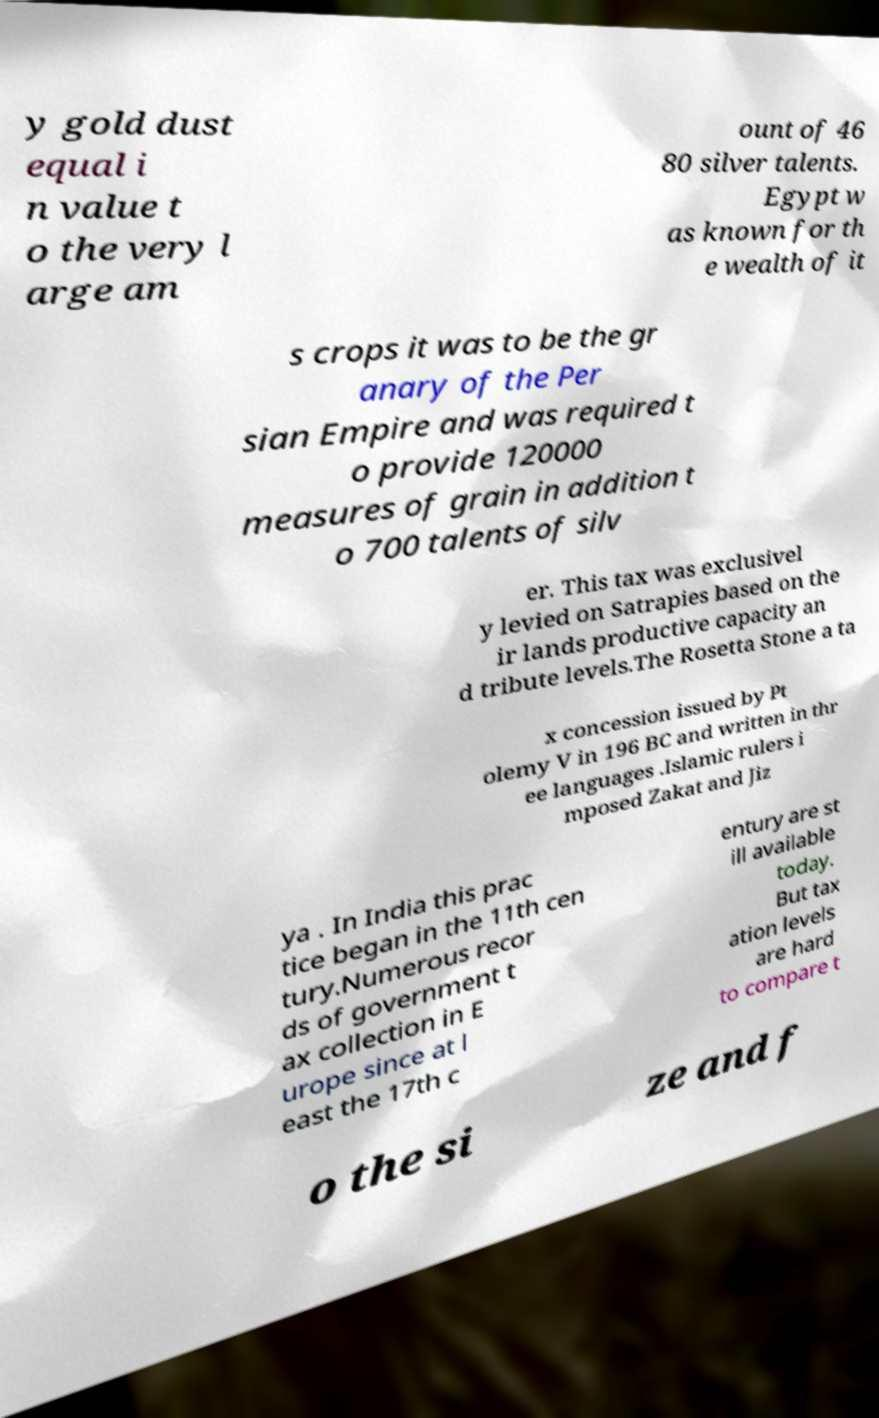For documentation purposes, I need the text within this image transcribed. Could you provide that? y gold dust equal i n value t o the very l arge am ount of 46 80 silver talents. Egypt w as known for th e wealth of it s crops it was to be the gr anary of the Per sian Empire and was required t o provide 120000 measures of grain in addition t o 700 talents of silv er. This tax was exclusivel y levied on Satrapies based on the ir lands productive capacity an d tribute levels.The Rosetta Stone a ta x concession issued by Pt olemy V in 196 BC and written in thr ee languages .Islamic rulers i mposed Zakat and Jiz ya . In India this prac tice began in the 11th cen tury.Numerous recor ds of government t ax collection in E urope since at l east the 17th c entury are st ill available today. But tax ation levels are hard to compare t o the si ze and f 